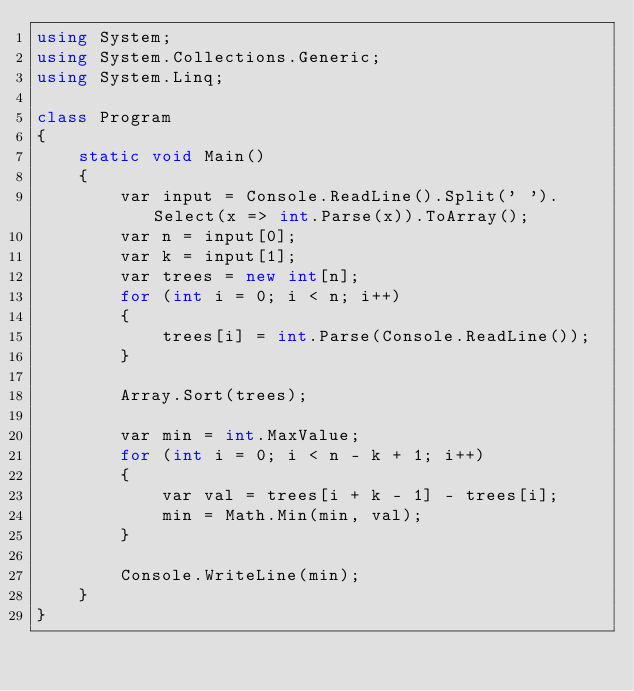<code> <loc_0><loc_0><loc_500><loc_500><_C#_>using System;
using System.Collections.Generic;
using System.Linq;

class Program
{
    static void Main()
    {
        var input = Console.ReadLine().Split(' ').Select(x => int.Parse(x)).ToArray();
        var n = input[0];
        var k = input[1];
        var trees = new int[n];
        for (int i = 0; i < n; i++)
        {
            trees[i] = int.Parse(Console.ReadLine());
        }

        Array.Sort(trees);

        var min = int.MaxValue;
        for (int i = 0; i < n - k + 1; i++)
        {
            var val = trees[i + k - 1] - trees[i];
            min = Math.Min(min, val);
        }

        Console.WriteLine(min);
    }
}</code> 